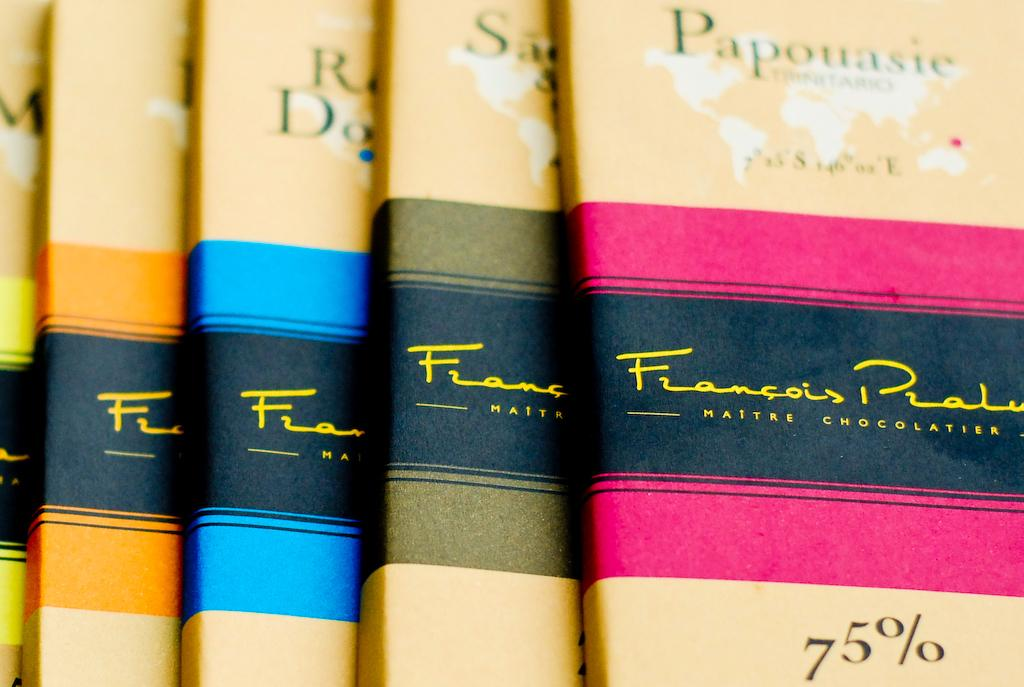<image>
Provide a brief description of the given image. A line of chocolate bars that say 75 percent on the package. 